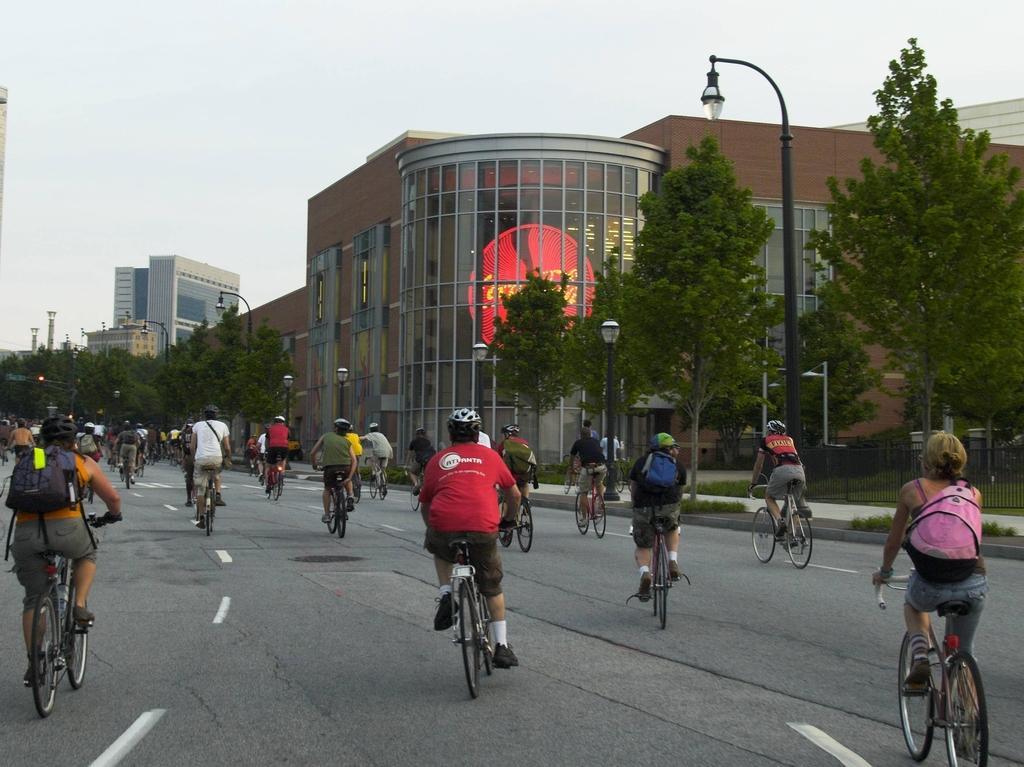Can you describe this image briefly? There is a road. On the road there are many people riding cycles. Some are wearing helmets and holding bag. On the right side there are buildings, trees and light poles. On the ground there is grass. In the background there are trees. 